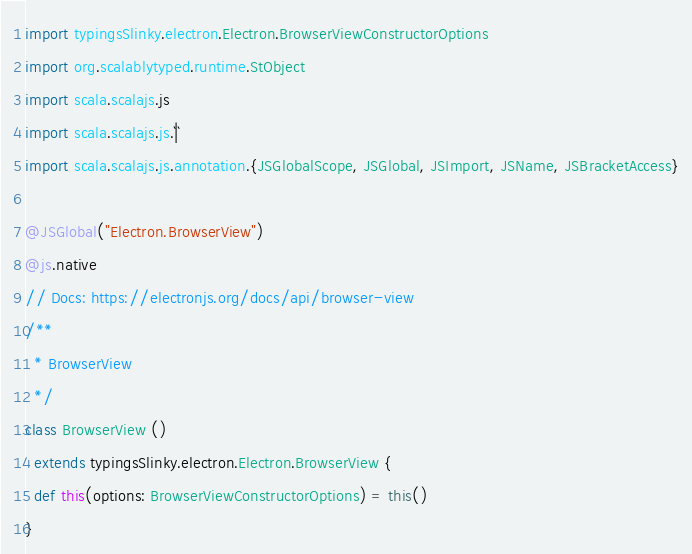<code> <loc_0><loc_0><loc_500><loc_500><_Scala_>import typingsSlinky.electron.Electron.BrowserViewConstructorOptions
import org.scalablytyped.runtime.StObject
import scala.scalajs.js
import scala.scalajs.js.`|`
import scala.scalajs.js.annotation.{JSGlobalScope, JSGlobal, JSImport, JSName, JSBracketAccess}

@JSGlobal("Electron.BrowserView")
@js.native
// Docs: https://electronjs.org/docs/api/browser-view
/**
  * BrowserView
  */
class BrowserView ()
  extends typingsSlinky.electron.Electron.BrowserView {
  def this(options: BrowserViewConstructorOptions) = this()
}
</code> 